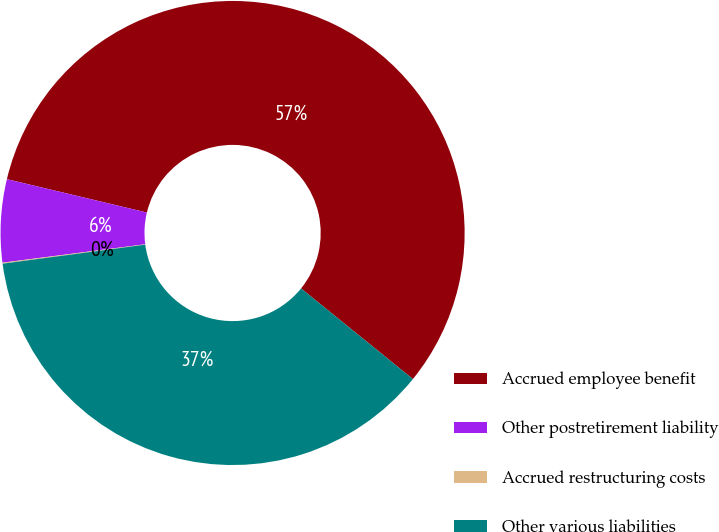Convert chart. <chart><loc_0><loc_0><loc_500><loc_500><pie_chart><fcel>Accrued employee benefit<fcel>Other postretirement liability<fcel>Accrued restructuring costs<fcel>Other various liabilities<nl><fcel>57.11%<fcel>5.77%<fcel>0.07%<fcel>37.05%<nl></chart> 